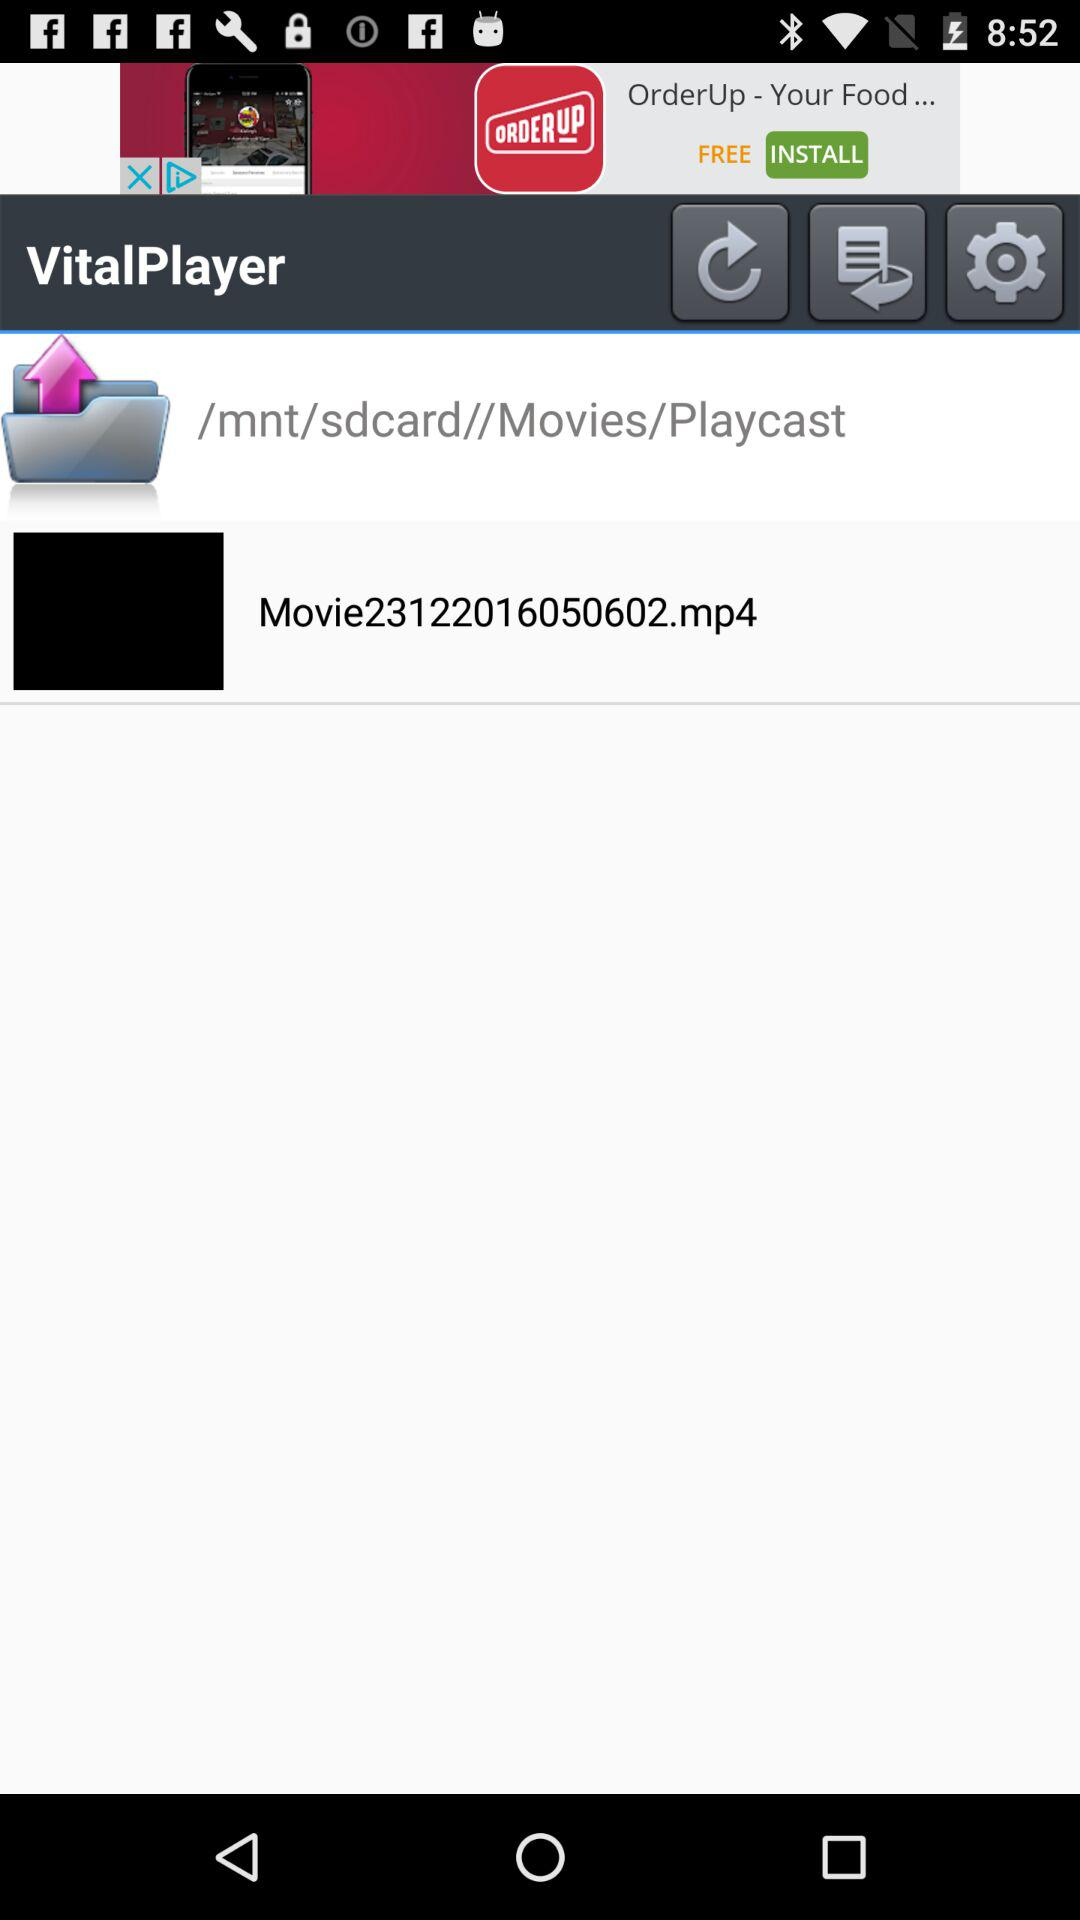What is the application name? The application name is "VitalPlayer". 